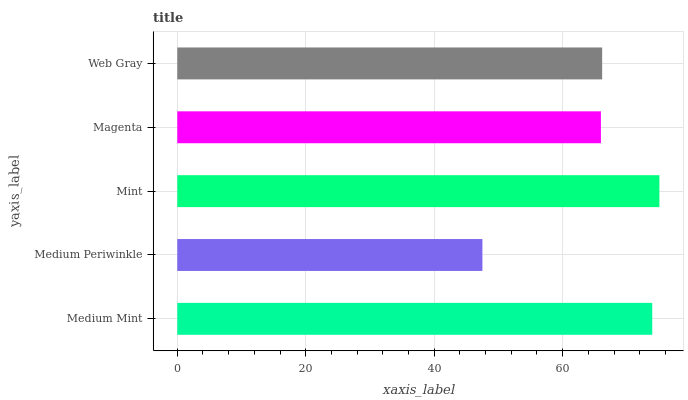Is Medium Periwinkle the minimum?
Answer yes or no. Yes. Is Mint the maximum?
Answer yes or no. Yes. Is Mint the minimum?
Answer yes or no. No. Is Medium Periwinkle the maximum?
Answer yes or no. No. Is Mint greater than Medium Periwinkle?
Answer yes or no. Yes. Is Medium Periwinkle less than Mint?
Answer yes or no. Yes. Is Medium Periwinkle greater than Mint?
Answer yes or no. No. Is Mint less than Medium Periwinkle?
Answer yes or no. No. Is Web Gray the high median?
Answer yes or no. Yes. Is Web Gray the low median?
Answer yes or no. Yes. Is Magenta the high median?
Answer yes or no. No. Is Magenta the low median?
Answer yes or no. No. 